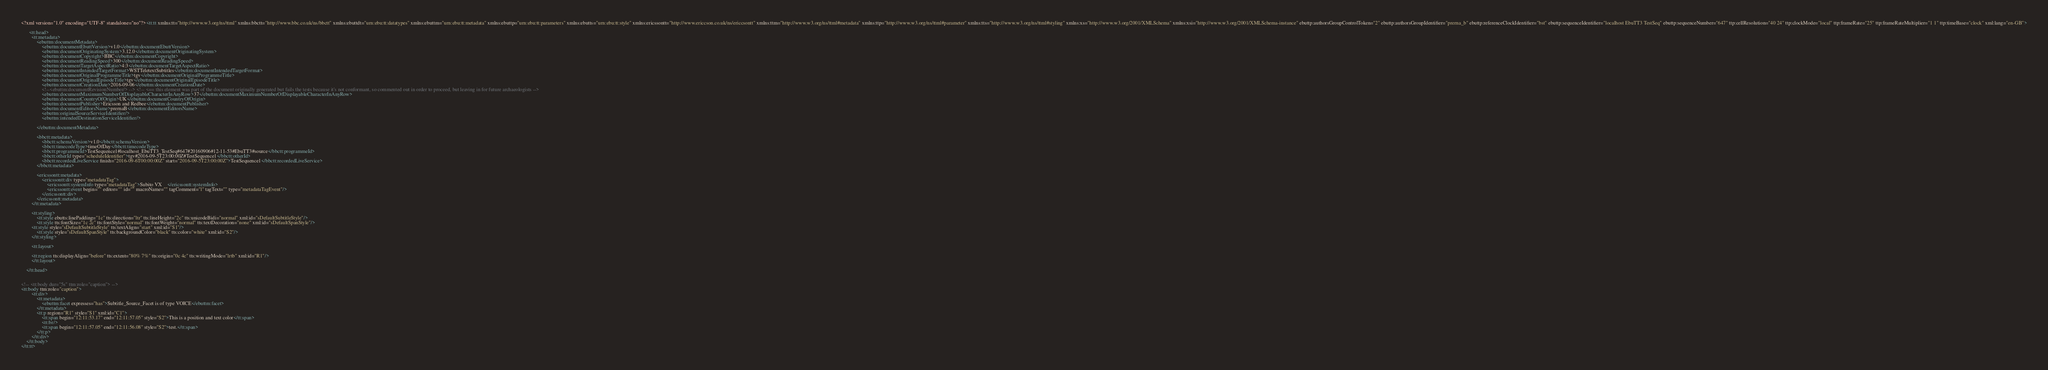Convert code to text. <code><loc_0><loc_0><loc_500><loc_500><_XML_><?xml version="1.0" encoding="UTF-8" standalone="no"?><tt:tt xmlns:tt="http://www.w3.org/ns/ttml" xmlns:bbctt="http://www.bbc.co.uk/ns/bbctt" xmlns:ebuttdt="urn:ebu:tt:datatypes" xmlns:ebuttm="urn:ebu:tt:metadata" xmlns:ebuttp="urn:ebu:tt:parameters" xmlns:ebutts="urn:ebu:tt:style" xmlns:ericssontt="http://www.ericcson.co.uk/ns/ericcsontt" xmlns:ttm="http://www.w3.org/ns/ttml#metadata" xmlns:ttp="http://www.w3.org/ns/ttml#parameter" xmlns:tts="http://www.w3.org/ns/ttml#styling" xmlns:xs="http://www.w3.org/2001/XMLSchema" xmlns:xsi="http://www.w3.org/2001/XMLSchema-instance" ebuttp:authorsGroupControlToken="2" ebuttp:authorsGroupIdentifier="prerna_b" ebuttp:referenceClockIdentifier="bst" ebuttp:sequenceIdentifier="localhost EbuTT3 TestSeq" ebuttp:sequenceNumber="647" ttp:cellResolution="40 24" ttp:clockMode="local" ttp:frameRate="25" ttp:frameRateMultiplier="1 1" ttp:timeBase="clock" xml:lang="en-GB">
       
      <tt:head>
        <tt:metadata>
            <ebuttm:documentMetadata>
                <ebuttm:documentEbuttVersion>v1.0</ebuttm:documentEbuttVersion>
                <ebuttm:documentOriginatingSystem>3.12.0</ebuttm:documentOriginatingSystem>
                <ebuttm:documentCopyright>BBC</ebuttm:documentCopyright>
                <ebuttm:documentReadingSpeed>300</ebuttm:documentReadingSpeed>
                <ebuttm:documentTargetAspectRatio>4:3</ebuttm:documentTargetAspectRatio>
                <ebuttm:documentIntendedTargetFormat>WSTTeletextSubtitles</ebuttm:documentIntendedTargetFormat>
                <ebuttm:documentOriginalProgrammeTitle>tgv</ebuttm:documentOriginalProgrammeTitle>
                <ebuttm:documentOriginalEpisodeTitle>tgv</ebuttm:documentOriginalEpisodeTitle>
                <ebuttm:documentCreationDate>2016-09-06</ebuttm:documentCreationDate>
                <!--<ebuttm:documentRevisionNumber/> --> <!-- <== this element was part of the document originally generated but fails the tests because it's not conformant, so commented out in order to proceed, but leaving in for future archaeologists -->
                <ebuttm:documentMaximumNumberOfDisplayableCharacterInAnyRow>37</ebuttm:documentMaximumNumberOfDisplayableCharacterInAnyRow>
                <ebuttm:documentCountryOfOrigin>UK</ebuttm:documentCountryOfOrigin>
                <ebuttm:documentPublisher>Ericsson and Redbee</ebuttm:documentPublisher>
                <ebuttm:documentEditorsName>prernaB</ebuttm:documentEditorsName>
                <ebuttm:originalSourceServiceIdentifier/>
                <ebuttm:intendedDestinationServiceIdentifier/>
    
            </ebuttm:documentMetadata>

            <bbctt:metadata>
                <bbctt:schemaVersion>v1.0</bbctt:schemaVersion>
                <bbctt:timecodeType>timeOfDay</bbctt:timecodeType>
                <bbctt:programmeId>TestSequence1#localhost_EbuTT3_TestSeq#647#20160906#12-11-53#EbuTT3#source</bbctt:programmeId>
                <bbctt:otherId type="scheduleIdentifier">tgv#2016-09-5T23:00:00Z#TestSequence1</bbctt:otherId>
                <bbctt:recordedLiveService finish="2016-09-6T00:00:00Z" start="2016-09-5T23:00:00Z">TestSequence1</bbctt:recordedLiveService>
            </bbctt:metadata>

            <ericssontt:metadata>
                <ericssontt:div type="metadataTag">
                    <ericssontt:systemInfo type="metadataTag">Subito VX    </ericssontt:systemInfo>
                    <ericssontt:event begin="" editor="" id="" macroName="" tagComment="l" tagText="" type="metadataTagEvent"/>
                </ericssontt:div>
            </ericssontt:metadata>
        </tt:metadata>

        <tt:styling>
            <tt:style ebutts:linePadding="1c" tts:direction="ltr" tts:lineHeight="2c" tts:unicodeBidi="normal" xml:id="sDefaultSubtitleStyle"/>
            <tt:style tts:fontSize="1c 2c" tts:fontStyle="normal" tts:fontWeight="normal" tts:textDecoration="none" xml:id="sDefaultSpanStyle"/>
        <tt:style style="sDefaultSubtitleStyle" tts:textAlign="start" xml:id="S1"/>
            <tt:style style="sDefaultSpanStyle" tts:backgroundColor="black" tts:color="white" xml:id="S2"/>
        </tt:styling>
        
        <tt:layout>
            
        <tt:region tts:displayAlign="before" tts:extent="80% 7%" tts:origin="0c 4c" tts:writingMode="lrtb" xml:id="R1"/>
        </tt:layout>

    </tt:head>

    
<!-- <tt:body dur="5s" ttm:role="caption"> -->
<tt:body ttm:role="caption">
        <tt:div>
            <tt:metadata>
                <ebuttm:facet expresses="has">Subtitle_Source_Facet is of type VOICE</ebuttm:facet>
            </tt:metadata>
            <tt:p region="R1" style="S1" xml:id="C1">
                <tt:span begin="12:11:53.17" end="12:11:57.05" style="S2">This is a position and text color</tt:span>
                <tt:br/>
                <tt:span begin="12:11:57.05" end="12:11:56.08" style="S2">test.</tt:span>
            </tt:p>
        </tt:div>
    </tt:body>
</tt:tt>
</code> 